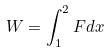Convert formula to latex. <formula><loc_0><loc_0><loc_500><loc_500>W = \int _ { 1 } ^ { 2 } F d x</formula> 